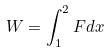Convert formula to latex. <formula><loc_0><loc_0><loc_500><loc_500>W = \int _ { 1 } ^ { 2 } F d x</formula> 